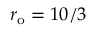Convert formula to latex. <formula><loc_0><loc_0><loc_500><loc_500>r _ { o } = 1 0 / 3</formula> 